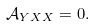Convert formula to latex. <formula><loc_0><loc_0><loc_500><loc_500>\mathcal { A } _ { Y X X } = 0 .</formula> 